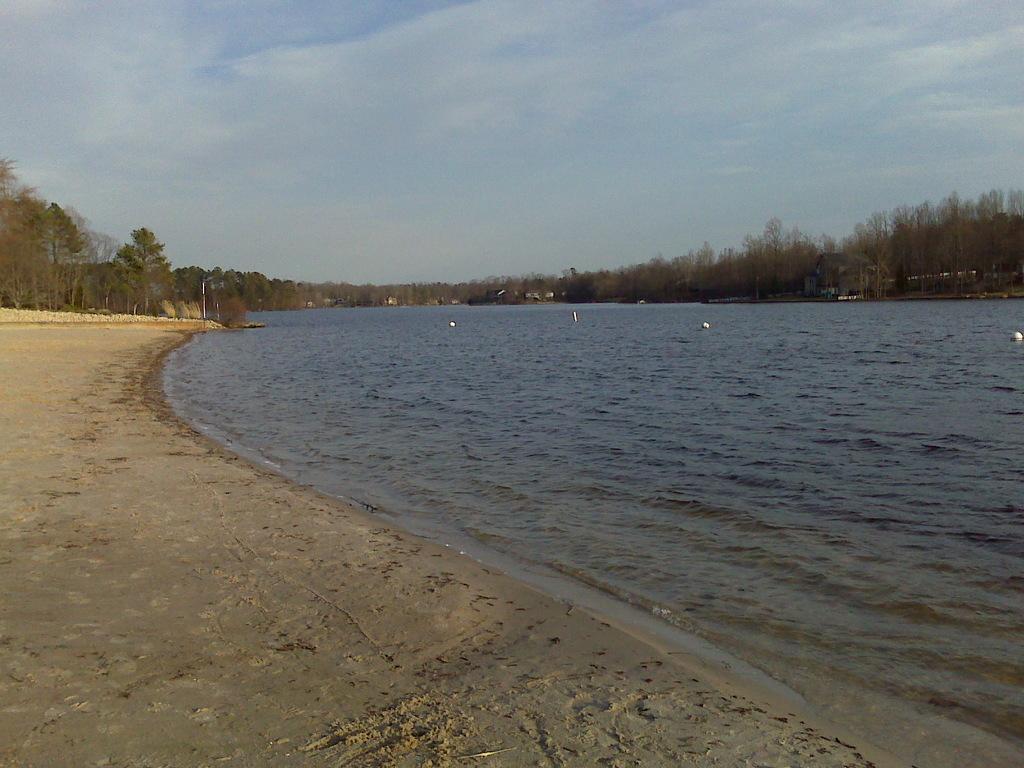How would you summarize this image in a sentence or two? In this image we can see group of objects floating on water. In the background, we can see a group of trees, poles and the cloudy sky. 